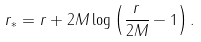Convert formula to latex. <formula><loc_0><loc_0><loc_500><loc_500>r _ { * } = r + 2 M \log \left ( \frac { r } { 2 M } - 1 \right ) .</formula> 